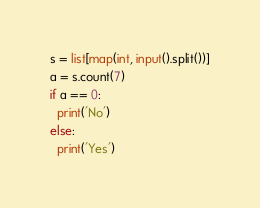<code> <loc_0><loc_0><loc_500><loc_500><_Python_>s = list[map(int, input().split())]
a = s.count(7)
if a == 0:
  print('No')
else:
  print('Yes')</code> 